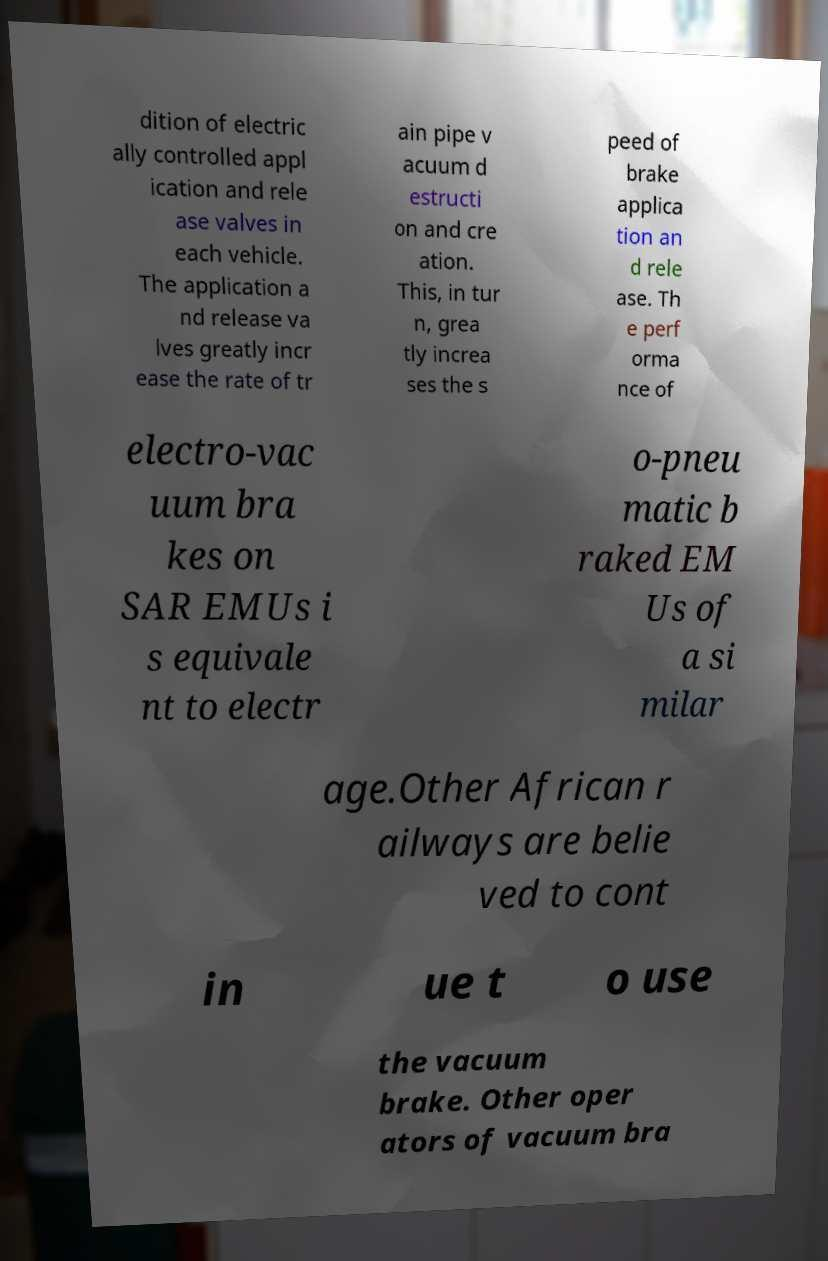Could you extract and type out the text from this image? dition of electric ally controlled appl ication and rele ase valves in each vehicle. The application a nd release va lves greatly incr ease the rate of tr ain pipe v acuum d estructi on and cre ation. This, in tur n, grea tly increa ses the s peed of brake applica tion an d rele ase. Th e perf orma nce of electro-vac uum bra kes on SAR EMUs i s equivale nt to electr o-pneu matic b raked EM Us of a si milar age.Other African r ailways are belie ved to cont in ue t o use the vacuum brake. Other oper ators of vacuum bra 